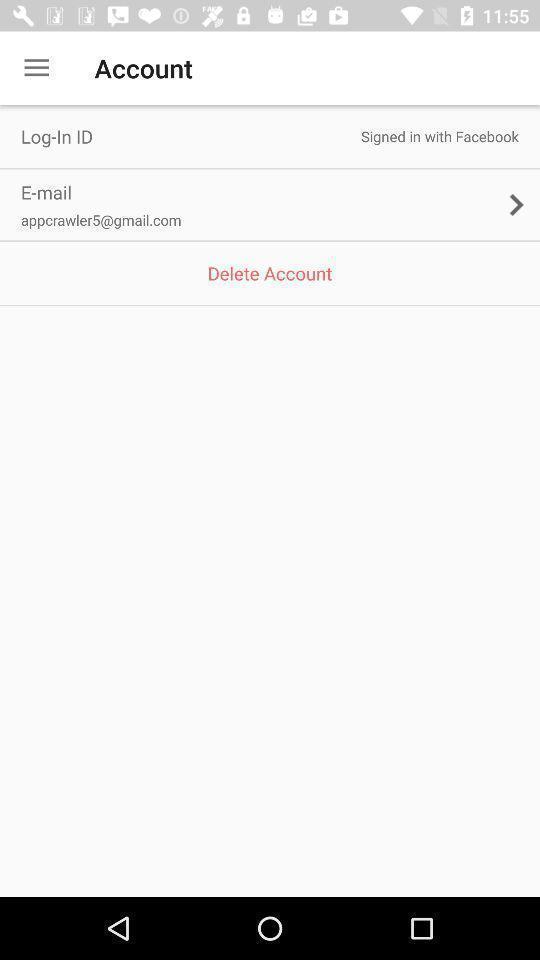What details can you identify in this image? Screen displaying user email credentials. 